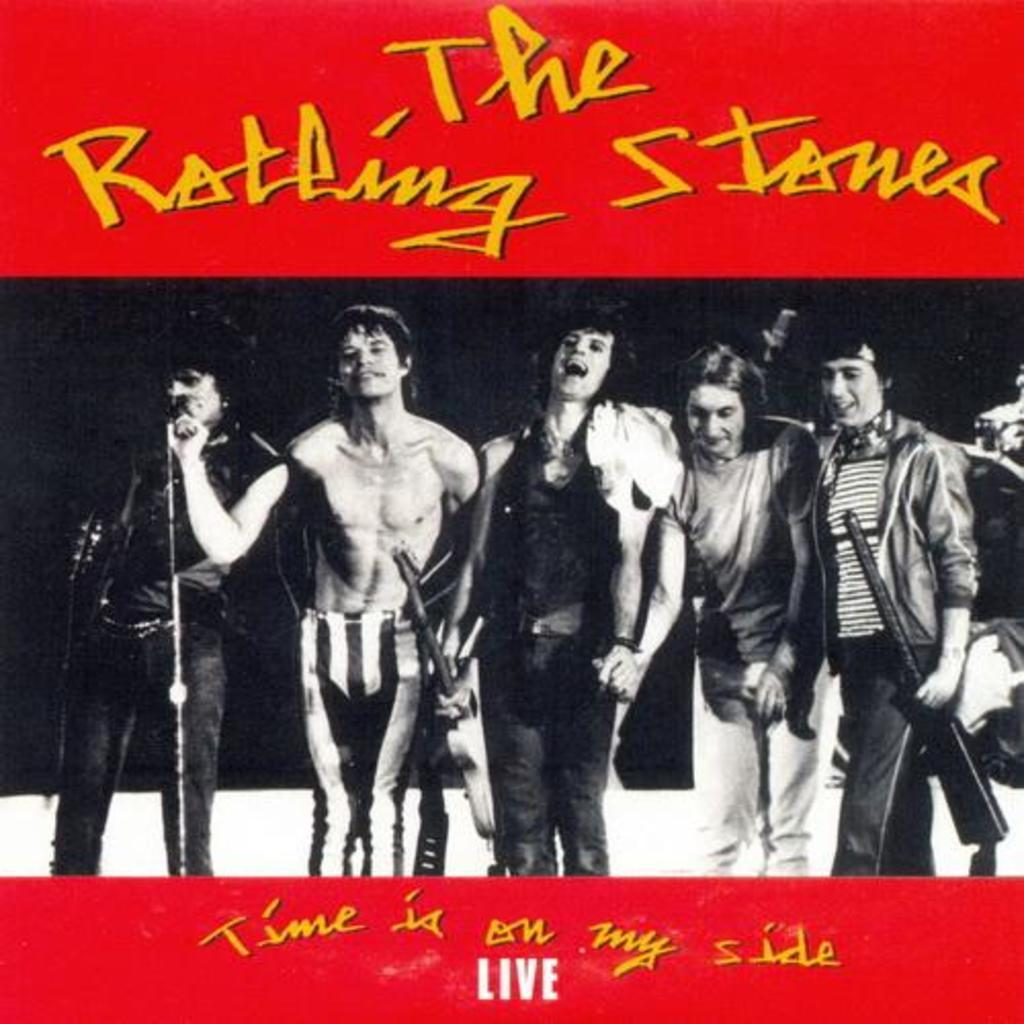What can be seen in the image involving people? There are people standing in the image. What are the people wearing? The people are wearing clothes. What musical instrument is present in the image? There is a guitar in the image. What device is used for amplifying sound in the image? There is a microphone in the image. What else can be seen in the image besides the people, guitar, and microphone? There is another object in the image, as well as text. How many dogs are present in the image? There are no dogs present in the image. What type of bell can be seen hanging from the guitar in the image? There is no bell present in the image, and the guitar is not shown hanging from anything. 